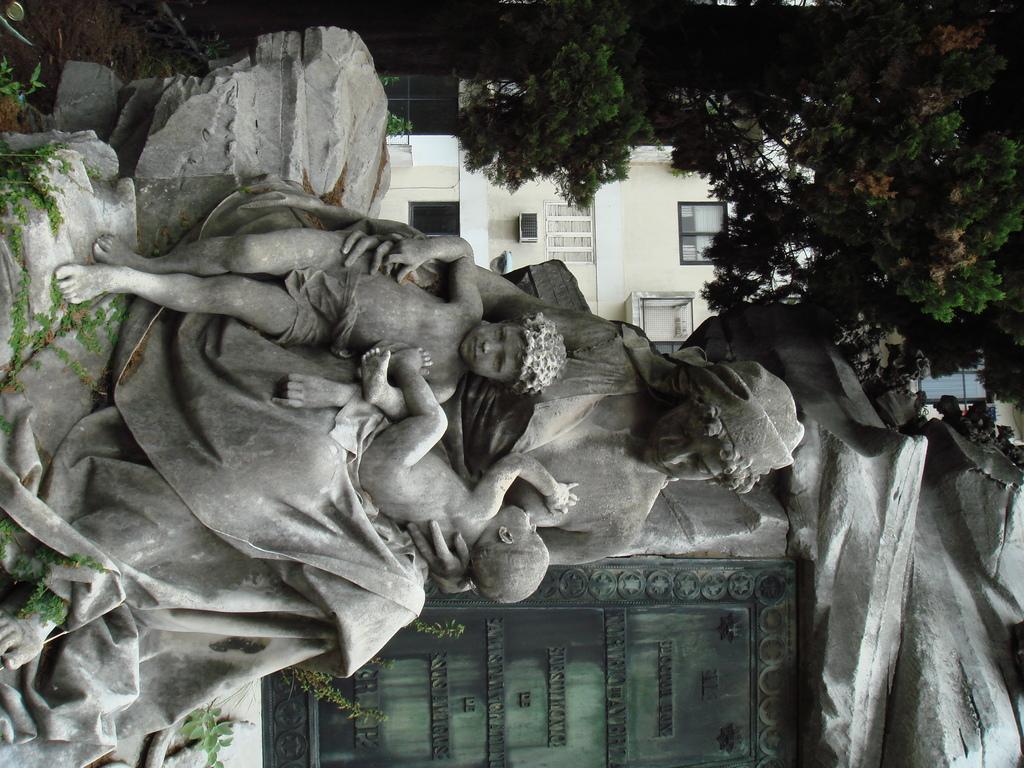Can you describe this image briefly? In this image there is a statue of a woman having two kids on her lap. Top of image there are few trees. Behind it there is a building having windows. 